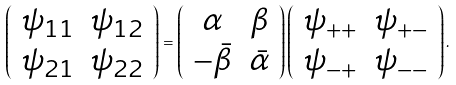Convert formula to latex. <formula><loc_0><loc_0><loc_500><loc_500>\left ( \begin{array} { c c } \psi _ { 1 1 } & \psi _ { 1 2 } \\ \psi _ { 2 1 } & \psi _ { 2 2 } \end{array} \right ) = \left ( \begin{array} { c c } \alpha & \beta \\ - \bar { \beta } & \bar { \alpha } \end{array} \right ) \left ( \begin{array} { c c } \psi _ { + + } & \psi _ { + - } \\ \psi _ { - + } & \psi _ { - - } \end{array} \right ) .</formula> 